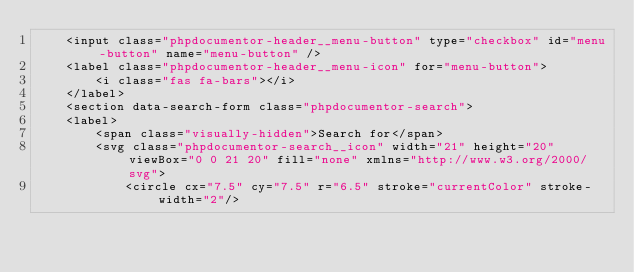Convert code to text. <code><loc_0><loc_0><loc_500><loc_500><_HTML_>    <input class="phpdocumentor-header__menu-button" type="checkbox" id="menu-button" name="menu-button" />
    <label class="phpdocumentor-header__menu-icon" for="menu-button">
        <i class="fas fa-bars"></i>
    </label>
    <section data-search-form class="phpdocumentor-search">
    <label>
        <span class="visually-hidden">Search for</span>
        <svg class="phpdocumentor-search__icon" width="21" height="20" viewBox="0 0 21 20" fill="none" xmlns="http://www.w3.org/2000/svg">
            <circle cx="7.5" cy="7.5" r="6.5" stroke="currentColor" stroke-width="2"/></code> 